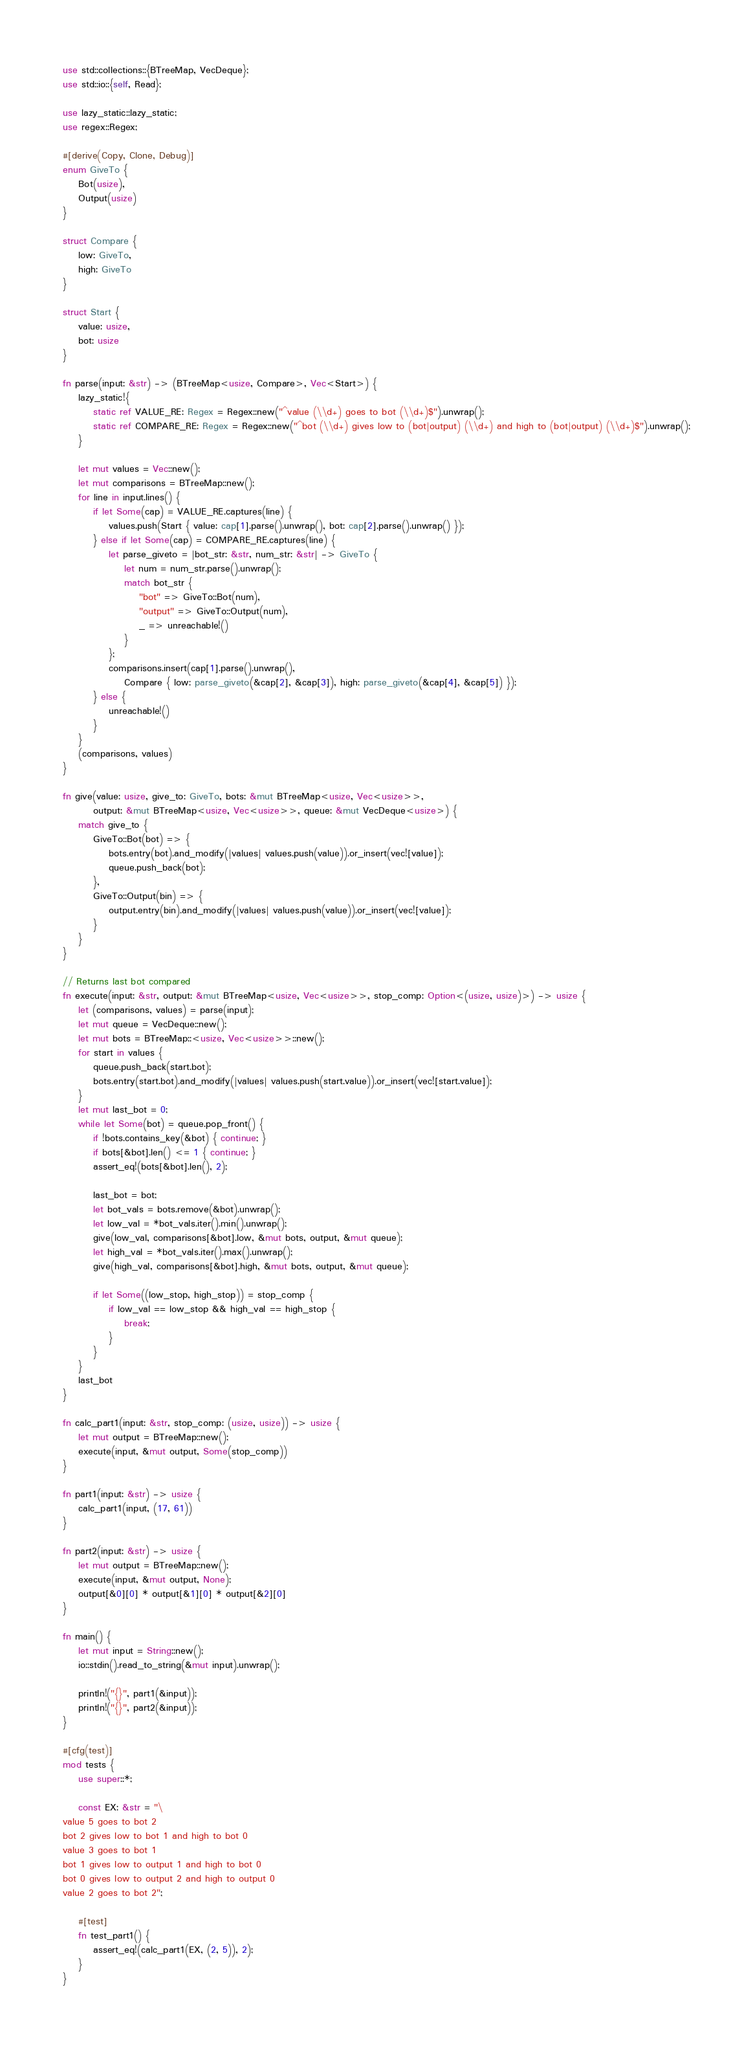Convert code to text. <code><loc_0><loc_0><loc_500><loc_500><_Rust_>use std::collections::{BTreeMap, VecDeque};
use std::io::{self, Read};

use lazy_static::lazy_static;
use regex::Regex;

#[derive(Copy, Clone, Debug)]
enum GiveTo {
    Bot(usize),
    Output(usize)
}

struct Compare {
    low: GiveTo,
    high: GiveTo
}

struct Start {
    value: usize,
    bot: usize
}

fn parse(input: &str) -> (BTreeMap<usize, Compare>, Vec<Start>) {
    lazy_static!{
        static ref VALUE_RE: Regex = Regex::new("^value (\\d+) goes to bot (\\d+)$").unwrap();
        static ref COMPARE_RE: Regex = Regex::new("^bot (\\d+) gives low to (bot|output) (\\d+) and high to (bot|output) (\\d+)$").unwrap();
    }

    let mut values = Vec::new();
    let mut comparisons = BTreeMap::new();
    for line in input.lines() {
        if let Some(cap) = VALUE_RE.captures(line) {
            values.push(Start { value: cap[1].parse().unwrap(), bot: cap[2].parse().unwrap() });
        } else if let Some(cap) = COMPARE_RE.captures(line) {
            let parse_giveto = |bot_str: &str, num_str: &str| -> GiveTo {
                let num = num_str.parse().unwrap();
                match bot_str {
                    "bot" => GiveTo::Bot(num),
                    "output" => GiveTo::Output(num),
                    _ => unreachable!()
                }
            };
            comparisons.insert(cap[1].parse().unwrap(),
                Compare { low: parse_giveto(&cap[2], &cap[3]), high: parse_giveto(&cap[4], &cap[5]) });
        } else {
            unreachable!()
        }
    }
    (comparisons, values)
}

fn give(value: usize, give_to: GiveTo, bots: &mut BTreeMap<usize, Vec<usize>>,
        output: &mut BTreeMap<usize, Vec<usize>>, queue: &mut VecDeque<usize>) {
    match give_to {
        GiveTo::Bot(bot) => {
            bots.entry(bot).and_modify(|values| values.push(value)).or_insert(vec![value]);
            queue.push_back(bot);
        },
        GiveTo::Output(bin) => {
            output.entry(bin).and_modify(|values| values.push(value)).or_insert(vec![value]);
        }
    }
}

// Returns last bot compared
fn execute(input: &str, output: &mut BTreeMap<usize, Vec<usize>>, stop_comp: Option<(usize, usize)>) -> usize {
    let (comparisons, values) = parse(input);
    let mut queue = VecDeque::new();
    let mut bots = BTreeMap::<usize, Vec<usize>>::new();
    for start in values {
        queue.push_back(start.bot);
        bots.entry(start.bot).and_modify(|values| values.push(start.value)).or_insert(vec![start.value]);
    }
    let mut last_bot = 0;
    while let Some(bot) = queue.pop_front() {
        if !bots.contains_key(&bot) { continue; }
        if bots[&bot].len() <= 1 { continue; }
        assert_eq!(bots[&bot].len(), 2);

        last_bot = bot;
        let bot_vals = bots.remove(&bot).unwrap();
        let low_val = *bot_vals.iter().min().unwrap();
        give(low_val, comparisons[&bot].low, &mut bots, output, &mut queue);
        let high_val = *bot_vals.iter().max().unwrap();
        give(high_val, comparisons[&bot].high, &mut bots, output, &mut queue);

        if let Some((low_stop, high_stop)) = stop_comp {
            if low_val == low_stop && high_val == high_stop {
                break;
            }
        }
    }
    last_bot
}

fn calc_part1(input: &str, stop_comp: (usize, usize)) -> usize {
    let mut output = BTreeMap::new();
    execute(input, &mut output, Some(stop_comp))
}

fn part1(input: &str) -> usize {
    calc_part1(input, (17, 61))
}

fn part2(input: &str) -> usize {
    let mut output = BTreeMap::new();
    execute(input, &mut output, None);
    output[&0][0] * output[&1][0] * output[&2][0]
}

fn main() {
    let mut input = String::new();
    io::stdin().read_to_string(&mut input).unwrap();

    println!("{}", part1(&input));
    println!("{}", part2(&input));
}

#[cfg(test)]
mod tests {
    use super::*;

    const EX: &str = "\
value 5 goes to bot 2
bot 2 gives low to bot 1 and high to bot 0
value 3 goes to bot 1
bot 1 gives low to output 1 and high to bot 0
bot 0 gives low to output 2 and high to output 0
value 2 goes to bot 2";

    #[test]
    fn test_part1() {
        assert_eq!(calc_part1(EX, (2, 5)), 2);
    }
}
</code> 